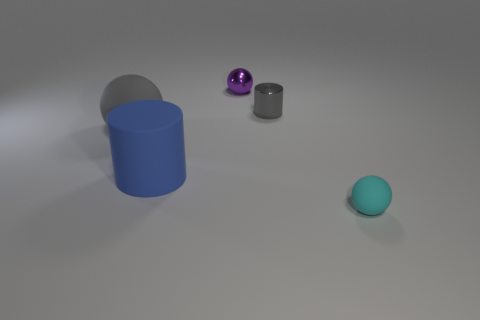What number of things are either rubber things or big rubber cylinders?
Keep it short and to the point. 3. Is there a large gray rubber object that has the same shape as the small cyan matte object?
Make the answer very short. Yes. Is the color of the small ball on the right side of the small purple ball the same as the large rubber sphere?
Offer a terse response. No. There is a big matte object that is to the left of the cylinder in front of the big gray ball; what shape is it?
Give a very brief answer. Sphere. Are there any red rubber things of the same size as the shiny cylinder?
Your answer should be very brief. No. Are there fewer tiny cyan metallic cylinders than tiny gray objects?
Offer a terse response. Yes. What is the shape of the small thing that is in front of the tiny metal object that is to the right of the small metal object behind the gray metallic cylinder?
Provide a short and direct response. Sphere. What number of objects are matte things that are on the left side of the big blue cylinder or rubber things that are behind the small rubber thing?
Give a very brief answer. 2. There is a purple sphere; are there any balls to the left of it?
Provide a short and direct response. Yes. What number of objects are matte balls that are on the right side of the rubber cylinder or red rubber cylinders?
Your answer should be compact. 1. 